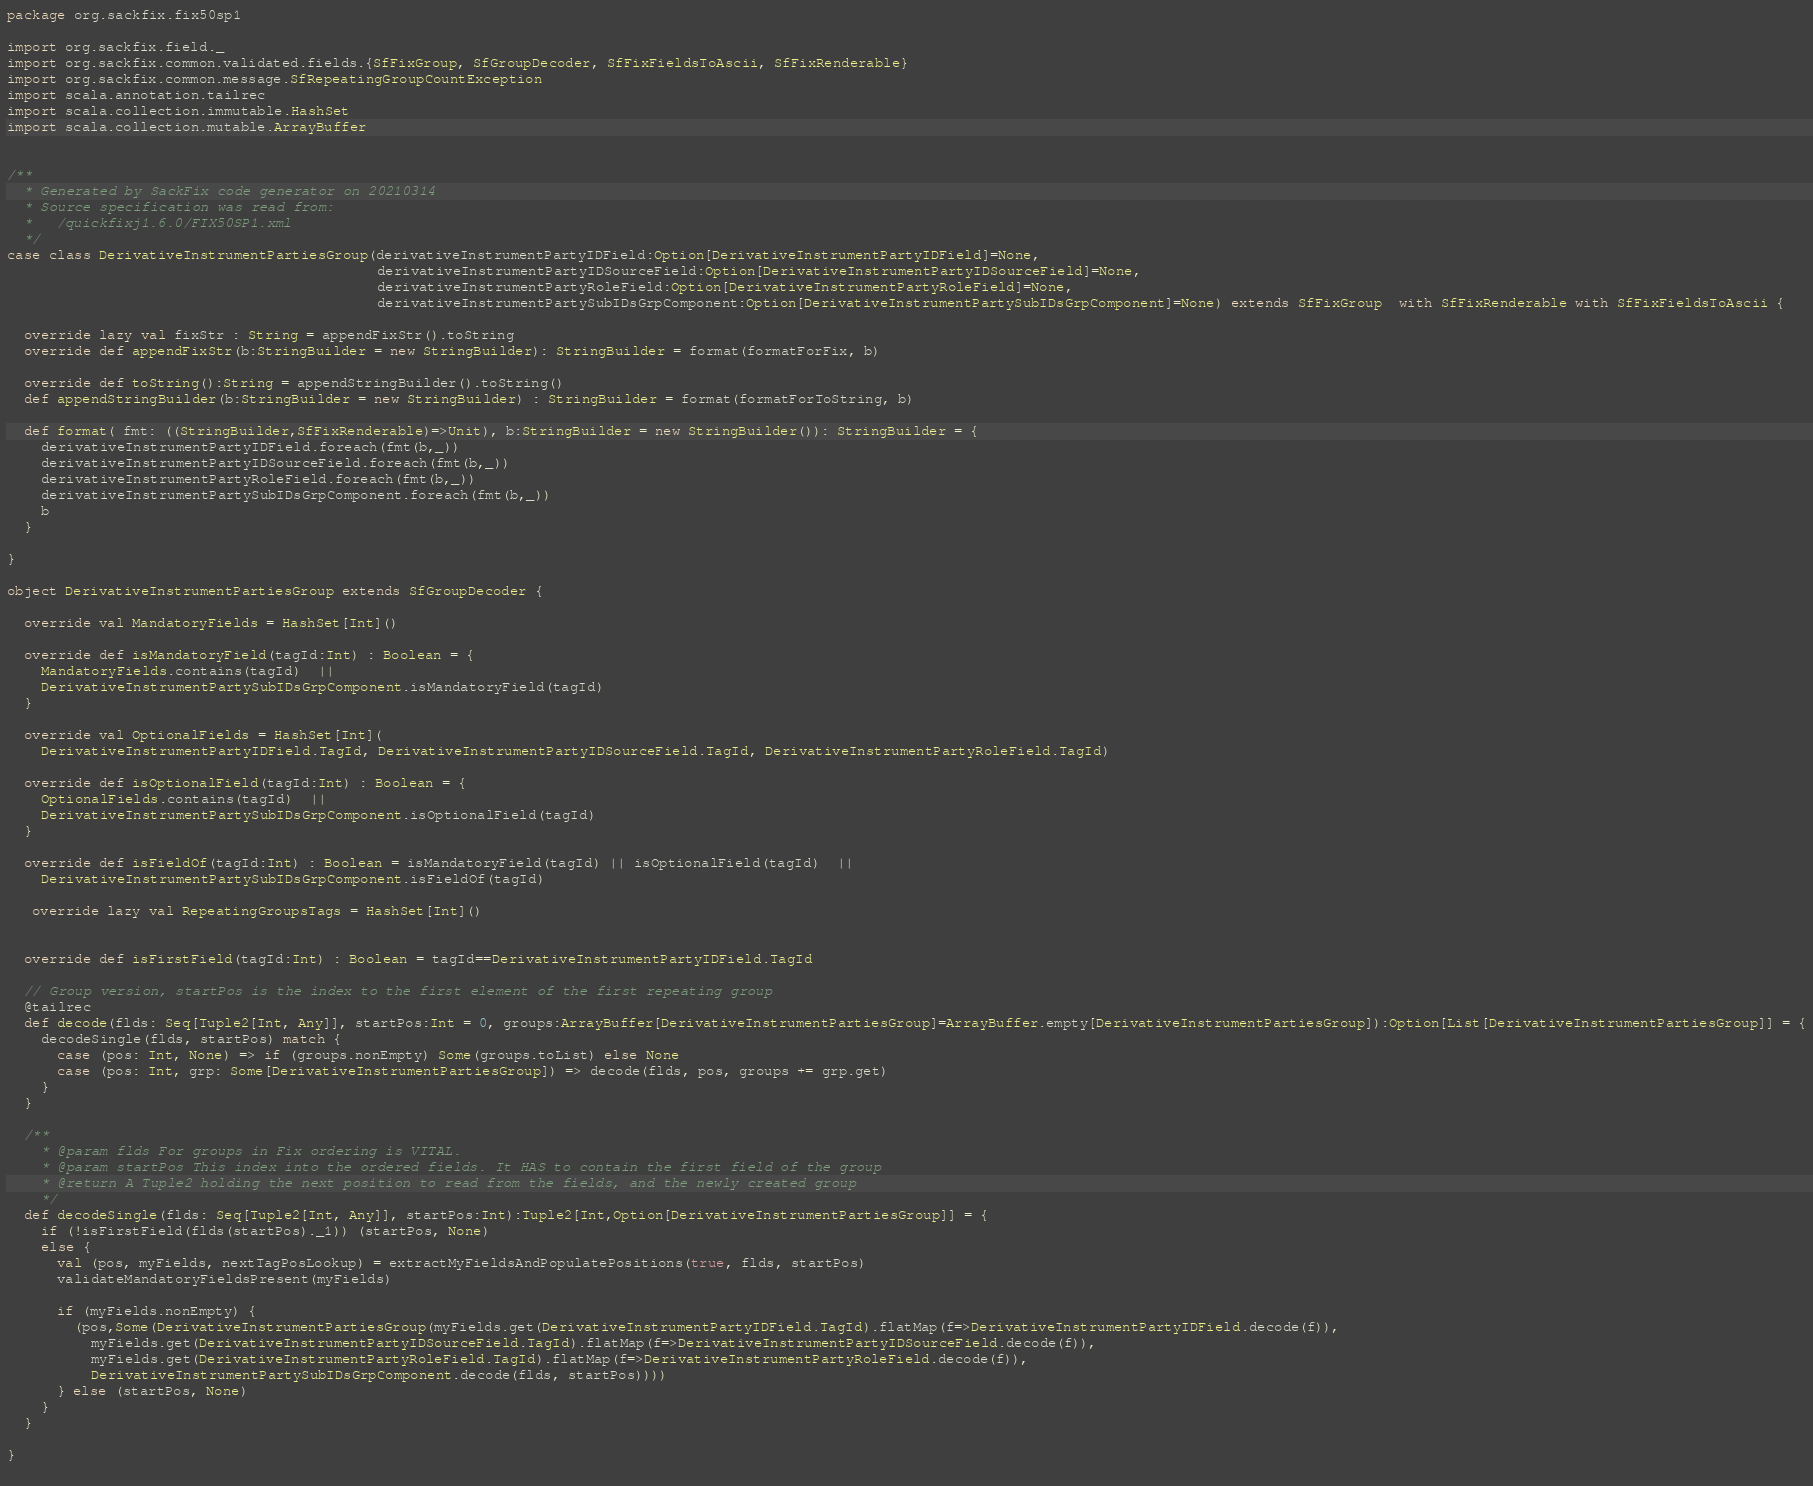<code> <loc_0><loc_0><loc_500><loc_500><_Scala_>package org.sackfix.fix50sp1

import org.sackfix.field._
import org.sackfix.common.validated.fields.{SfFixGroup, SfGroupDecoder, SfFixFieldsToAscii, SfFixRenderable}
import org.sackfix.common.message.SfRepeatingGroupCountException
import scala.annotation.tailrec
import scala.collection.immutable.HashSet
import scala.collection.mutable.ArrayBuffer


/**
  * Generated by SackFix code generator on 20210314
  * Source specification was read from:
  *   /quickfixj1.6.0/FIX50SP1.xml
  */
case class DerivativeInstrumentPartiesGroup(derivativeInstrumentPartyIDField:Option[DerivativeInstrumentPartyIDField]=None,
                                            derivativeInstrumentPartyIDSourceField:Option[DerivativeInstrumentPartyIDSourceField]=None,
                                            derivativeInstrumentPartyRoleField:Option[DerivativeInstrumentPartyRoleField]=None,
                                            derivativeInstrumentPartySubIDsGrpComponent:Option[DerivativeInstrumentPartySubIDsGrpComponent]=None) extends SfFixGroup  with SfFixRenderable with SfFixFieldsToAscii {

  override lazy val fixStr : String = appendFixStr().toString
  override def appendFixStr(b:StringBuilder = new StringBuilder): StringBuilder = format(formatForFix, b)

  override def toString():String = appendStringBuilder().toString()
  def appendStringBuilder(b:StringBuilder = new StringBuilder) : StringBuilder = format(formatForToString, b)

  def format( fmt: ((StringBuilder,SfFixRenderable)=>Unit), b:StringBuilder = new StringBuilder()): StringBuilder = {
    derivativeInstrumentPartyIDField.foreach(fmt(b,_))
    derivativeInstrumentPartyIDSourceField.foreach(fmt(b,_))
    derivativeInstrumentPartyRoleField.foreach(fmt(b,_))
    derivativeInstrumentPartySubIDsGrpComponent.foreach(fmt(b,_))
    b
  }

}
     
object DerivativeInstrumentPartiesGroup extends SfGroupDecoder {

  override val MandatoryFields = HashSet[Int]()

  override def isMandatoryField(tagId:Int) : Boolean = {
    MandatoryFields.contains(tagId)  || 
    DerivativeInstrumentPartySubIDsGrpComponent.isMandatoryField(tagId)
  }

  override val OptionalFields = HashSet[Int](
    DerivativeInstrumentPartyIDField.TagId, DerivativeInstrumentPartyIDSourceField.TagId, DerivativeInstrumentPartyRoleField.TagId)

  override def isOptionalField(tagId:Int) : Boolean = {
    OptionalFields.contains(tagId)  || 
    DerivativeInstrumentPartySubIDsGrpComponent.isOptionalField(tagId)
  }

  override def isFieldOf(tagId:Int) : Boolean = isMandatoryField(tagId) || isOptionalField(tagId)  || 
    DerivativeInstrumentPartySubIDsGrpComponent.isFieldOf(tagId)

   override lazy val RepeatingGroupsTags = HashSet[Int]()
  
      
  override def isFirstField(tagId:Int) : Boolean = tagId==DerivativeInstrumentPartyIDField.TagId 

  // Group version, startPos is the index to the first element of the first repeating group
  @tailrec
  def decode(flds: Seq[Tuple2[Int, Any]], startPos:Int = 0, groups:ArrayBuffer[DerivativeInstrumentPartiesGroup]=ArrayBuffer.empty[DerivativeInstrumentPartiesGroup]):Option[List[DerivativeInstrumentPartiesGroup]] = {
    decodeSingle(flds, startPos) match {
      case (pos: Int, None) => if (groups.nonEmpty) Some(groups.toList) else None
      case (pos: Int, grp: Some[DerivativeInstrumentPartiesGroup]) => decode(flds, pos, groups += grp.get)
    }
  }

  /**
    * @param flds For groups in Fix ordering is VITAL.
    * @param startPos This index into the ordered fields. It HAS to contain the first field of the group
    * @return A Tuple2 holding the next position to read from the fields, and the newly created group
    */
  def decodeSingle(flds: Seq[Tuple2[Int, Any]], startPos:Int):Tuple2[Int,Option[DerivativeInstrumentPartiesGroup]] = {
    if (!isFirstField(flds(startPos)._1)) (startPos, None)
    else {
      val (pos, myFields, nextTagPosLookup) = extractMyFieldsAndPopulatePositions(true, flds, startPos)
      validateMandatoryFieldsPresent(myFields)

      if (myFields.nonEmpty) {
        (pos,Some(DerivativeInstrumentPartiesGroup(myFields.get(DerivativeInstrumentPartyIDField.TagId).flatMap(f=>DerivativeInstrumentPartyIDField.decode(f)),
          myFields.get(DerivativeInstrumentPartyIDSourceField.TagId).flatMap(f=>DerivativeInstrumentPartyIDSourceField.decode(f)),
          myFields.get(DerivativeInstrumentPartyRoleField.TagId).flatMap(f=>DerivativeInstrumentPartyRoleField.decode(f)),
          DerivativeInstrumentPartySubIDsGrpComponent.decode(flds, startPos))))
      } else (startPos, None)
    }
  }
    
}
     </code> 